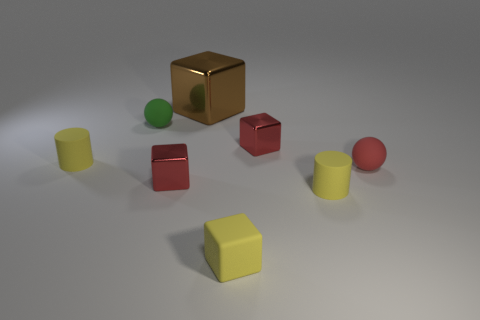Subtract all green cubes. Subtract all brown cylinders. How many cubes are left? 4 Add 1 big cyan metallic blocks. How many objects exist? 9 Subtract all cylinders. How many objects are left? 6 Subtract all large metallic blocks. Subtract all big brown metal things. How many objects are left? 6 Add 2 rubber spheres. How many rubber spheres are left? 4 Add 6 cyan metal cubes. How many cyan metal cubes exist? 6 Subtract 0 brown balls. How many objects are left? 8 